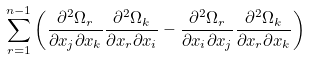<formula> <loc_0><loc_0><loc_500><loc_500>\sum _ { r = 1 } ^ { n - 1 } \left ( \frac { \partial ^ { 2 } \Omega _ { r } } { \partial x _ { j } \partial x _ { k } } \frac { \partial ^ { 2 } \Omega _ { k } } { \partial x _ { r } \partial x _ { i } } - \frac { \partial ^ { 2 } \Omega _ { r } } { \partial x _ { i } \partial x _ { j } } \frac { \partial ^ { 2 } \Omega _ { k } } { \partial x _ { r } \partial x _ { k } } \right )</formula> 